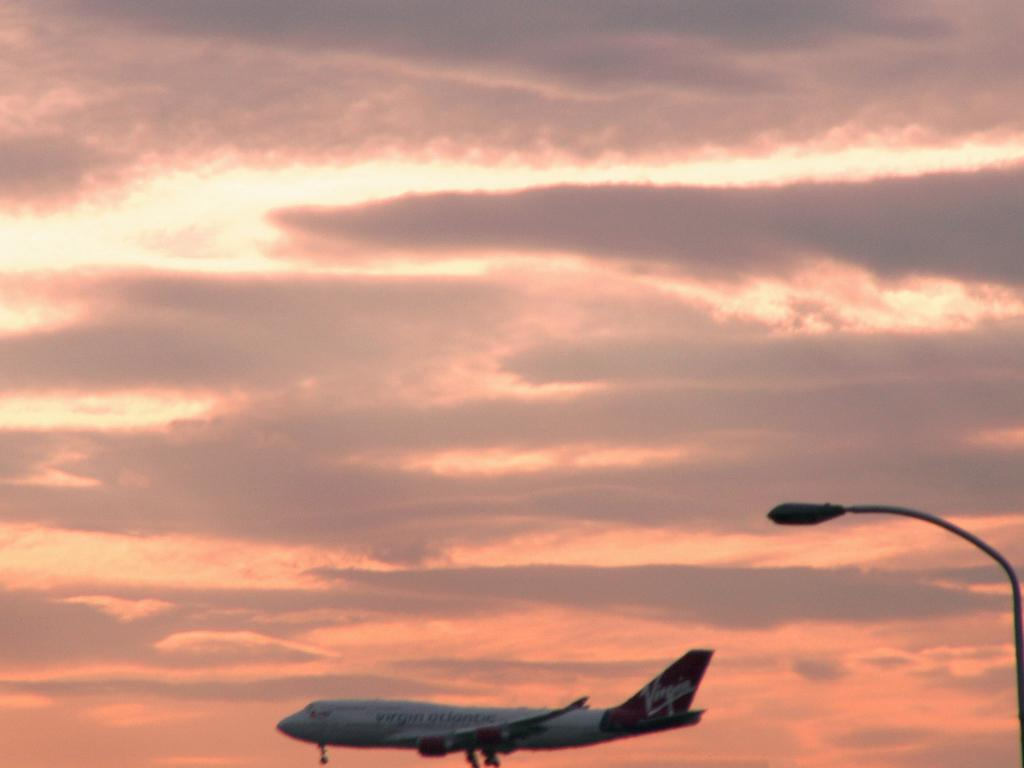What is the main subject of the image? The main subject of the image is an airplane. What can be seen on the right side of the image? There is a light pole on the right side of the image. What is visible in the background of the image? The sky is visible in the background of the image. Can you tell me how many members are in the band playing near the river in the image? There is no band or river present in the image; it features an airplane and a light pole. What type of advice might the grandfather give to the child in the image? There is no grandfather or child present in the image; it features an airplane and a light pole. 